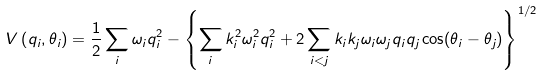<formula> <loc_0><loc_0><loc_500><loc_500>V \left ( q _ { i } , \theta _ { i } \right ) = \frac { 1 } { 2 } \sum _ { i } \omega _ { i } q _ { i } ^ { 2 } - \left \{ \sum _ { i } k _ { i } ^ { 2 } \omega _ { i } ^ { 2 } q _ { i } ^ { 2 } + 2 \sum _ { i < j } k _ { i } k _ { j } \omega _ { i } \omega _ { j } q _ { i } q _ { j } \cos ( \theta _ { i } - \theta _ { j } ) \right \} ^ { 1 / 2 }</formula> 